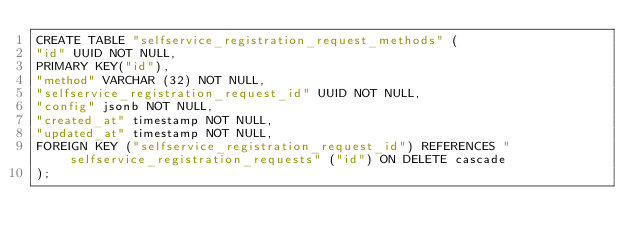Convert code to text. <code><loc_0><loc_0><loc_500><loc_500><_SQL_>CREATE TABLE "selfservice_registration_request_methods" (
"id" UUID NOT NULL,
PRIMARY KEY("id"),
"method" VARCHAR (32) NOT NULL,
"selfservice_registration_request_id" UUID NOT NULL,
"config" jsonb NOT NULL,
"created_at" timestamp NOT NULL,
"updated_at" timestamp NOT NULL,
FOREIGN KEY ("selfservice_registration_request_id") REFERENCES "selfservice_registration_requests" ("id") ON DELETE cascade
);</code> 